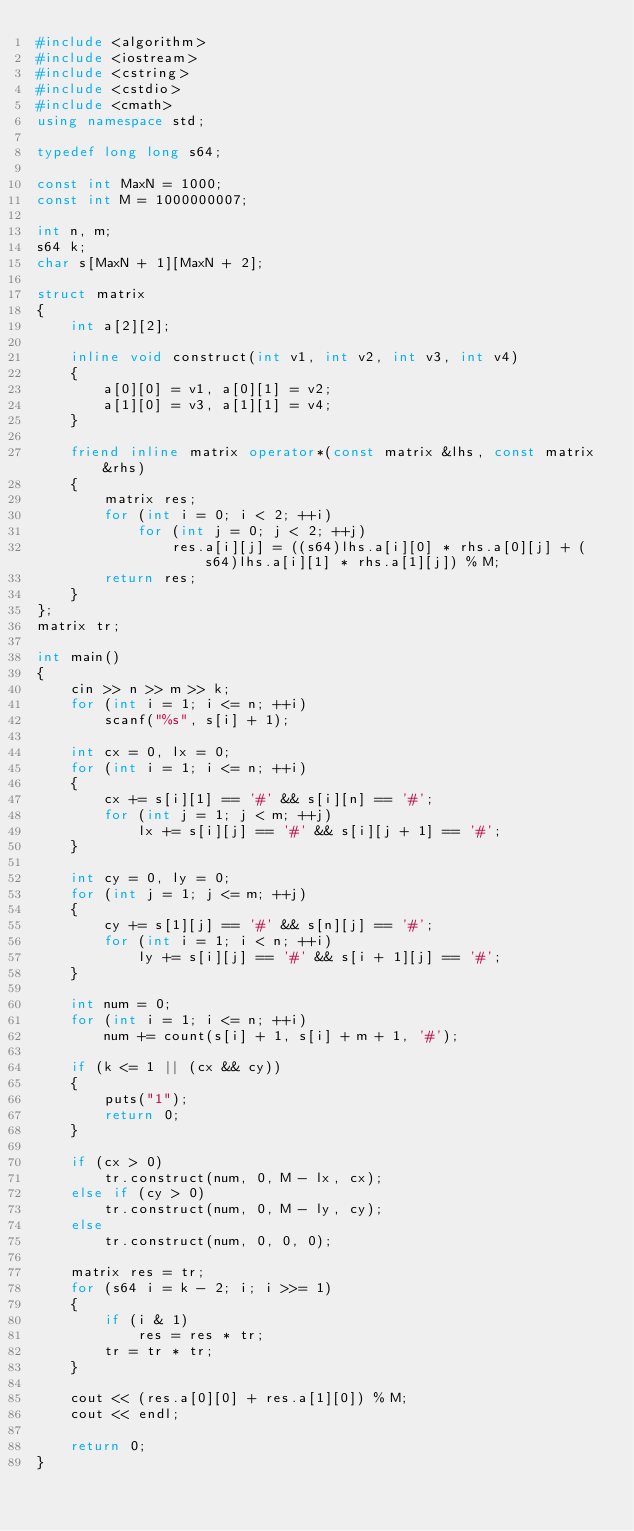<code> <loc_0><loc_0><loc_500><loc_500><_C++_>#include <algorithm>
#include <iostream>
#include <cstring>
#include <cstdio>
#include <cmath>
using namespace std;

typedef long long s64;

const int MaxN = 1000;
const int M = 1000000007;

int n, m;
s64 k;
char s[MaxN + 1][MaxN + 2];

struct matrix
{
	int a[2][2];

	inline void construct(int v1, int v2, int v3, int v4)
	{
		a[0][0] = v1, a[0][1] = v2;
		a[1][0] = v3, a[1][1] = v4;
	}

	friend inline matrix operator*(const matrix &lhs, const matrix &rhs)
	{
		matrix res;
		for (int i = 0; i < 2; ++i)
			for (int j = 0; j < 2; ++j)
				res.a[i][j] = ((s64)lhs.a[i][0] * rhs.a[0][j] + (s64)lhs.a[i][1] * rhs.a[1][j]) % M;
		return res;
	}
};
matrix tr;

int main()
{
	cin >> n >> m >> k;
	for (int i = 1; i <= n; ++i)
		scanf("%s", s[i] + 1);

	int cx = 0, lx = 0;
	for (int i = 1; i <= n; ++i)
	{
		cx += s[i][1] == '#' && s[i][n] == '#';
		for (int j = 1; j < m; ++j)
			lx += s[i][j] == '#' && s[i][j + 1] == '#';
	}

	int cy = 0, ly = 0;
	for (int j = 1; j <= m; ++j)
	{
		cy += s[1][j] == '#' && s[n][j] == '#';
		for (int i = 1; i < n; ++i)
			ly += s[i][j] == '#' && s[i + 1][j] == '#';
	}

	int num = 0;
	for (int i = 1; i <= n; ++i)
		num += count(s[i] + 1, s[i] + m + 1, '#');

	if (k <= 1 || (cx && cy))
	{
		puts("1");
		return 0;
	}

	if (cx > 0)
		tr.construct(num, 0, M - lx, cx);
	else if (cy > 0)
		tr.construct(num, 0, M - ly, cy);
	else
		tr.construct(num, 0, 0, 0);

	matrix res = tr;
	for (s64 i = k - 2; i; i >>= 1)
	{
		if (i & 1)
			res = res * tr;
		tr = tr * tr;
	}

	cout << (res.a[0][0] + res.a[1][0]) % M;
	cout << endl;

	return 0;
}</code> 